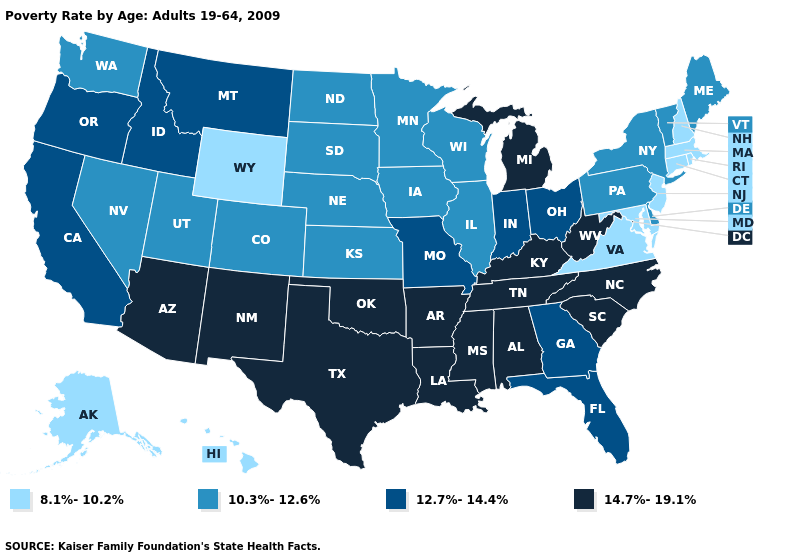Does Ohio have the highest value in the USA?
Give a very brief answer. No. Name the states that have a value in the range 8.1%-10.2%?
Quick response, please. Alaska, Connecticut, Hawaii, Maryland, Massachusetts, New Hampshire, New Jersey, Rhode Island, Virginia, Wyoming. Name the states that have a value in the range 8.1%-10.2%?
Keep it brief. Alaska, Connecticut, Hawaii, Maryland, Massachusetts, New Hampshire, New Jersey, Rhode Island, Virginia, Wyoming. What is the highest value in the South ?
Give a very brief answer. 14.7%-19.1%. Does Wisconsin have a higher value than Arizona?
Answer briefly. No. What is the value of Illinois?
Answer briefly. 10.3%-12.6%. Which states hav the highest value in the South?
Be succinct. Alabama, Arkansas, Kentucky, Louisiana, Mississippi, North Carolina, Oklahoma, South Carolina, Tennessee, Texas, West Virginia. Is the legend a continuous bar?
Write a very short answer. No. Does Hawaii have the same value as Maryland?
Concise answer only. Yes. Name the states that have a value in the range 8.1%-10.2%?
Give a very brief answer. Alaska, Connecticut, Hawaii, Maryland, Massachusetts, New Hampshire, New Jersey, Rhode Island, Virginia, Wyoming. What is the lowest value in the USA?
Concise answer only. 8.1%-10.2%. Which states have the highest value in the USA?
Short answer required. Alabama, Arizona, Arkansas, Kentucky, Louisiana, Michigan, Mississippi, New Mexico, North Carolina, Oklahoma, South Carolina, Tennessee, Texas, West Virginia. Name the states that have a value in the range 12.7%-14.4%?
Answer briefly. California, Florida, Georgia, Idaho, Indiana, Missouri, Montana, Ohio, Oregon. What is the value of Idaho?
Write a very short answer. 12.7%-14.4%. Among the states that border Oklahoma , which have the highest value?
Short answer required. Arkansas, New Mexico, Texas. 